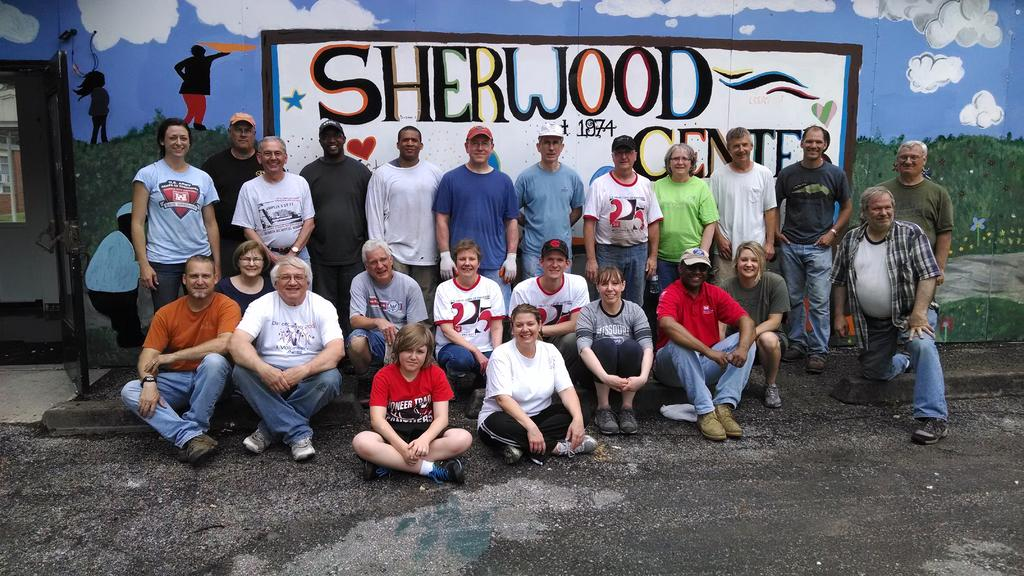How many people are in the image? There is a group of people in the image, but the exact number is not specified. What is the position of the people in the image? The people are on the ground in the image. What can be seen in the background of the image? There is an object and a wall with a painting in the background of the image. How does the peace symbol appear in the image? There is no peace symbol present in the image. Can you describe the light source in the image? The facts provided do not mention any light source in the image. 